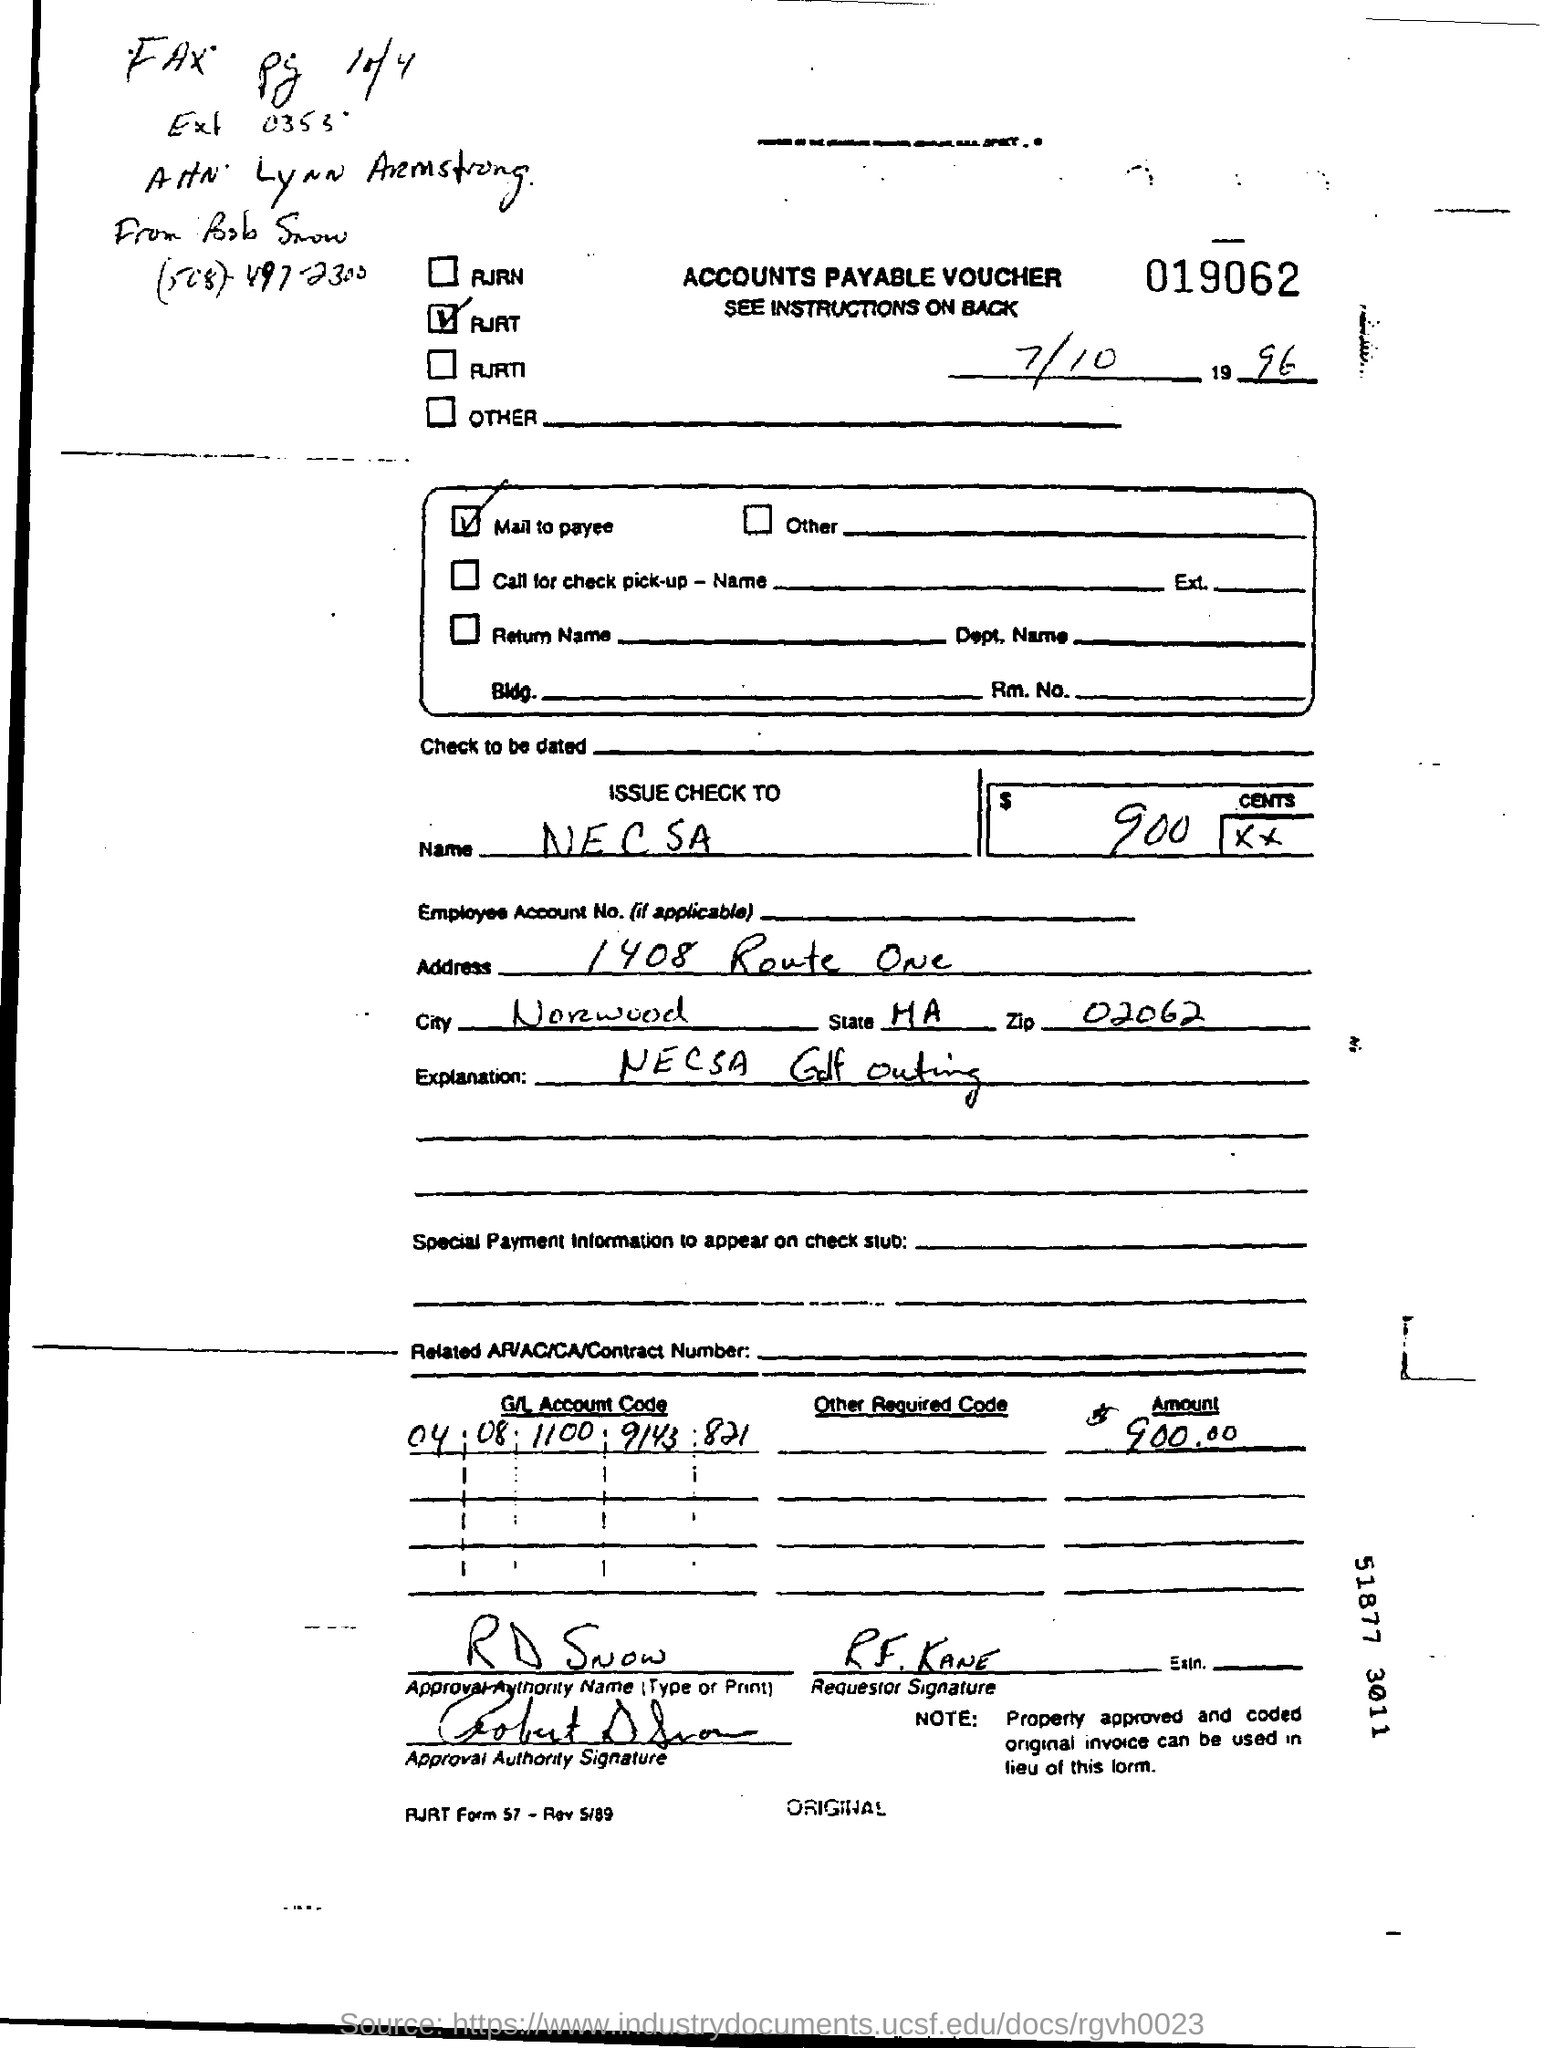Indicate a few pertinent items in this graphic. The approval authority for the voucher is R. D. Snow. The voucher states that the G/L account code mentioned in the transaction is 04 08 1100 9143 821. The check is issued to 'N E C S A' in the name of. The zip code mentioned in the address is 02062. The voucher indicates that $900 is being provided. 